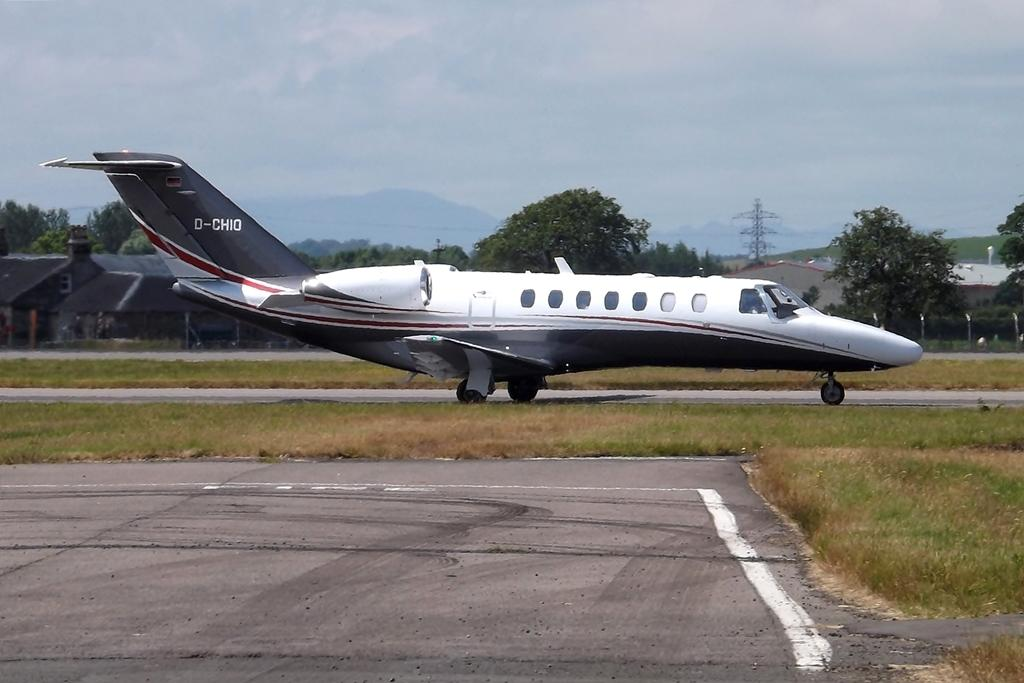<image>
Offer a succinct explanation of the picture presented. A small plane, D-CHIO, is parked outside with houses visible in the background. 